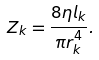<formula> <loc_0><loc_0><loc_500><loc_500>Z _ { k } = \frac { 8 \eta l _ { k } } { \pi r _ { k } ^ { 4 } } .</formula> 